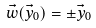<formula> <loc_0><loc_0><loc_500><loc_500>\vec { w } ( \vec { y } _ { 0 } ) = \pm \vec { y } _ { 0 }</formula> 